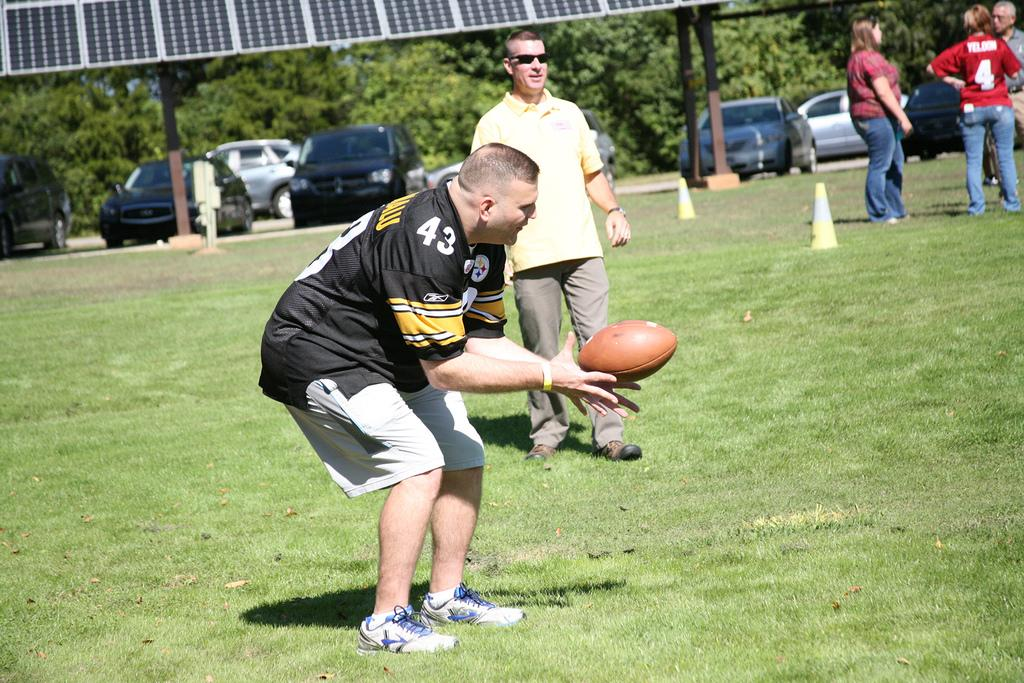<image>
Summarize the visual content of the image. A man holding a football ball and has jersey has the number 43 on it. 